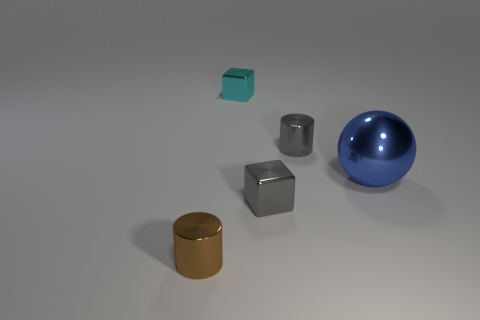The tiny cylinder that is to the right of the small brown metal thing is what color?
Offer a terse response. Gray. There is a gray thing that is the same shape as the brown shiny thing; what is its size?
Make the answer very short. Small. What number of objects are small shiny things in front of the gray shiny cylinder or metal things that are right of the small brown thing?
Provide a succinct answer. 5. There is a metal thing that is in front of the blue metallic object and on the right side of the tiny cyan cube; how big is it?
Offer a terse response. Small. Do the small cyan metal object and the small gray thing behind the blue sphere have the same shape?
Keep it short and to the point. No. How many objects are either tiny metallic cylinders that are behind the brown metallic cylinder or big green spheres?
Offer a very short reply. 1. Are the brown thing and the gray thing that is behind the big sphere made of the same material?
Your answer should be compact. Yes. There is a small gray object in front of the shiny cylinder that is on the right side of the small brown shiny cylinder; what shape is it?
Provide a short and direct response. Cube. Do the large thing and the small cube that is on the right side of the tiny cyan cube have the same color?
Offer a very short reply. No. What is the shape of the blue object?
Offer a terse response. Sphere. 